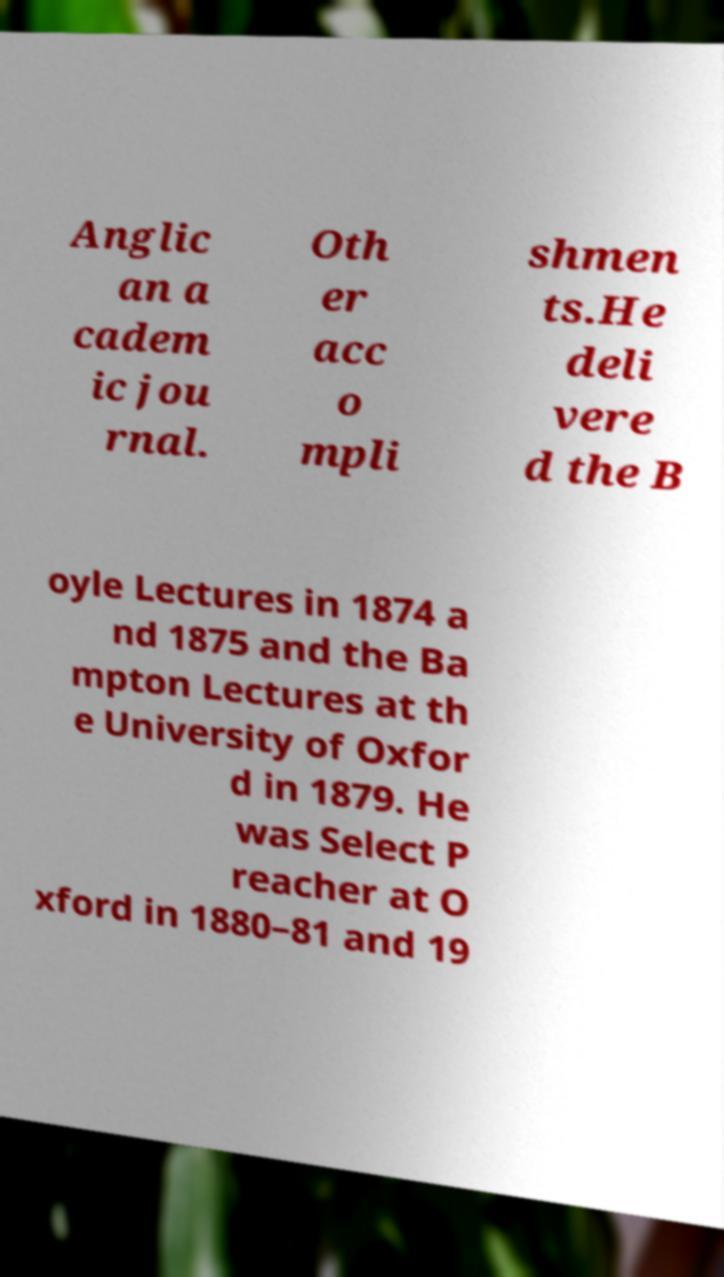Could you assist in decoding the text presented in this image and type it out clearly? Anglic an a cadem ic jou rnal. Oth er acc o mpli shmen ts.He deli vere d the B oyle Lectures in 1874 a nd 1875 and the Ba mpton Lectures at th e University of Oxfor d in 1879. He was Select P reacher at O xford in 1880–81 and 19 